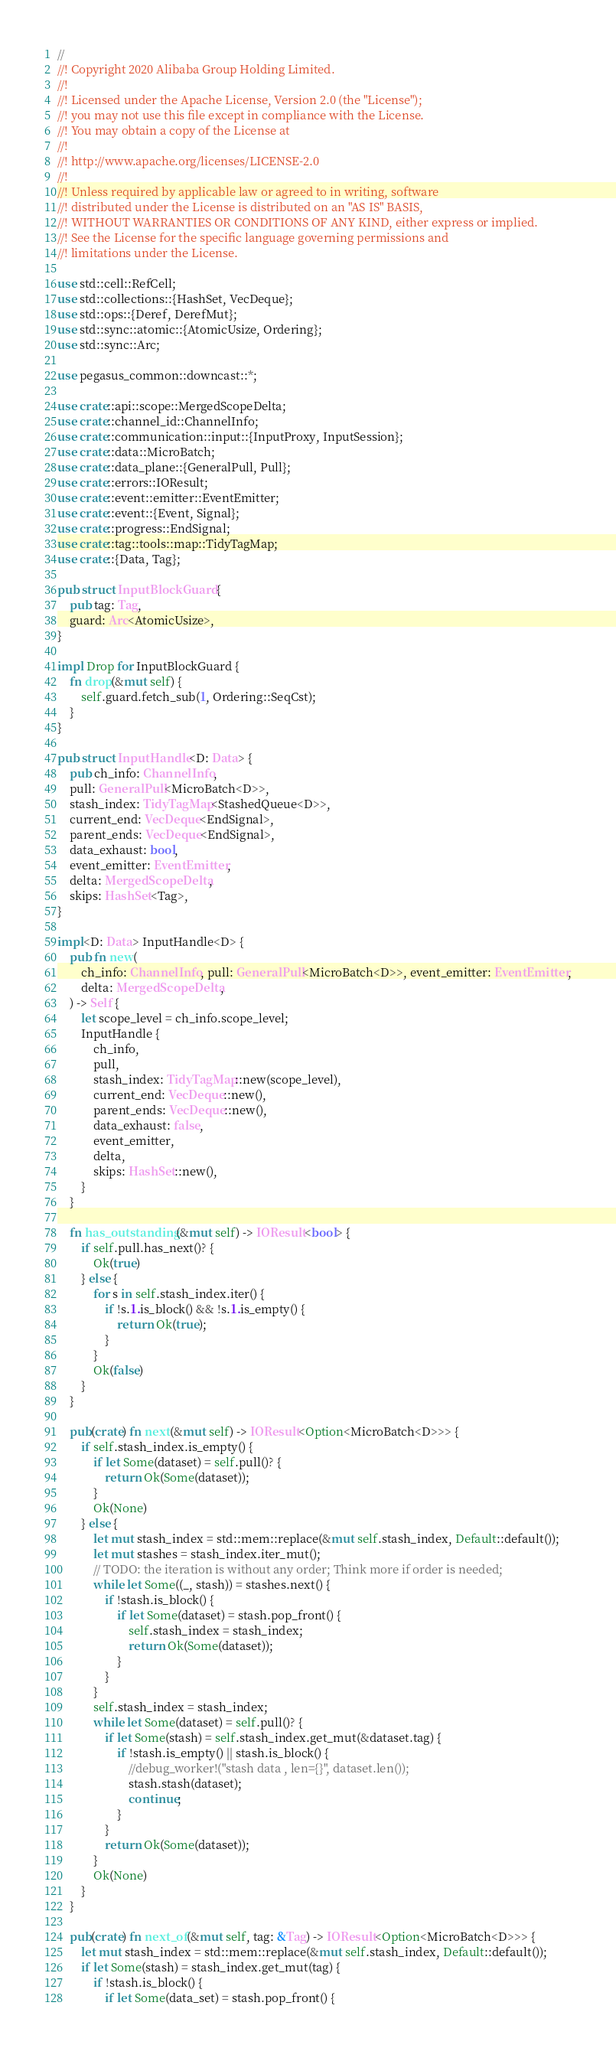<code> <loc_0><loc_0><loc_500><loc_500><_Rust_>//
//! Copyright 2020 Alibaba Group Holding Limited.
//!
//! Licensed under the Apache License, Version 2.0 (the "License");
//! you may not use this file except in compliance with the License.
//! You may obtain a copy of the License at
//!
//! http://www.apache.org/licenses/LICENSE-2.0
//!
//! Unless required by applicable law or agreed to in writing, software
//! distributed under the License is distributed on an "AS IS" BASIS,
//! WITHOUT WARRANTIES OR CONDITIONS OF ANY KIND, either express or implied.
//! See the License for the specific language governing permissions and
//! limitations under the License.

use std::cell::RefCell;
use std::collections::{HashSet, VecDeque};
use std::ops::{Deref, DerefMut};
use std::sync::atomic::{AtomicUsize, Ordering};
use std::sync::Arc;

use pegasus_common::downcast::*;

use crate::api::scope::MergedScopeDelta;
use crate::channel_id::ChannelInfo;
use crate::communication::input::{InputProxy, InputSession};
use crate::data::MicroBatch;
use crate::data_plane::{GeneralPull, Pull};
use crate::errors::IOResult;
use crate::event::emitter::EventEmitter;
use crate::event::{Event, Signal};
use crate::progress::EndSignal;
use crate::tag::tools::map::TidyTagMap;
use crate::{Data, Tag};

pub struct InputBlockGuard {
    pub tag: Tag,
    guard: Arc<AtomicUsize>,
}

impl Drop for InputBlockGuard {
    fn drop(&mut self) {
        self.guard.fetch_sub(1, Ordering::SeqCst);
    }
}

pub struct InputHandle<D: Data> {
    pub ch_info: ChannelInfo,
    pull: GeneralPull<MicroBatch<D>>,
    stash_index: TidyTagMap<StashedQueue<D>>,
    current_end: VecDeque<EndSignal>,
    parent_ends: VecDeque<EndSignal>,
    data_exhaust: bool,
    event_emitter: EventEmitter,
    delta: MergedScopeDelta,
    skips: HashSet<Tag>,
}

impl<D: Data> InputHandle<D> {
    pub fn new(
        ch_info: ChannelInfo, pull: GeneralPull<MicroBatch<D>>, event_emitter: EventEmitter,
        delta: MergedScopeDelta,
    ) -> Self {
        let scope_level = ch_info.scope_level;
        InputHandle {
            ch_info,
            pull,
            stash_index: TidyTagMap::new(scope_level),
            current_end: VecDeque::new(),
            parent_ends: VecDeque::new(),
            data_exhaust: false,
            event_emitter,
            delta,
            skips: HashSet::new(),
        }
    }

    fn has_outstanding(&mut self) -> IOResult<bool> {
        if self.pull.has_next()? {
            Ok(true)
        } else {
            for s in self.stash_index.iter() {
                if !s.1.is_block() && !s.1.is_empty() {
                    return Ok(true);
                }
            }
            Ok(false)
        }
    }

    pub(crate) fn next(&mut self) -> IOResult<Option<MicroBatch<D>>> {
        if self.stash_index.is_empty() {
            if let Some(dataset) = self.pull()? {
                return Ok(Some(dataset));
            }
            Ok(None)
        } else {
            let mut stash_index = std::mem::replace(&mut self.stash_index, Default::default());
            let mut stashes = stash_index.iter_mut();
            // TODO: the iteration is without any order; Think more if order is needed;
            while let Some((_, stash)) = stashes.next() {
                if !stash.is_block() {
                    if let Some(dataset) = stash.pop_front() {
                        self.stash_index = stash_index;
                        return Ok(Some(dataset));
                    }
                }
            }
            self.stash_index = stash_index;
            while let Some(dataset) = self.pull()? {
                if let Some(stash) = self.stash_index.get_mut(&dataset.tag) {
                    if !stash.is_empty() || stash.is_block() {
                        //debug_worker!("stash data , len={}", dataset.len());
                        stash.stash(dataset);
                        continue;
                    }
                }
                return Ok(Some(dataset));
            }
            Ok(None)
        }
    }

    pub(crate) fn next_of(&mut self, tag: &Tag) -> IOResult<Option<MicroBatch<D>>> {
        let mut stash_index = std::mem::replace(&mut self.stash_index, Default::default());
        if let Some(stash) = stash_index.get_mut(tag) {
            if !stash.is_block() {
                if let Some(data_set) = stash.pop_front() {</code> 